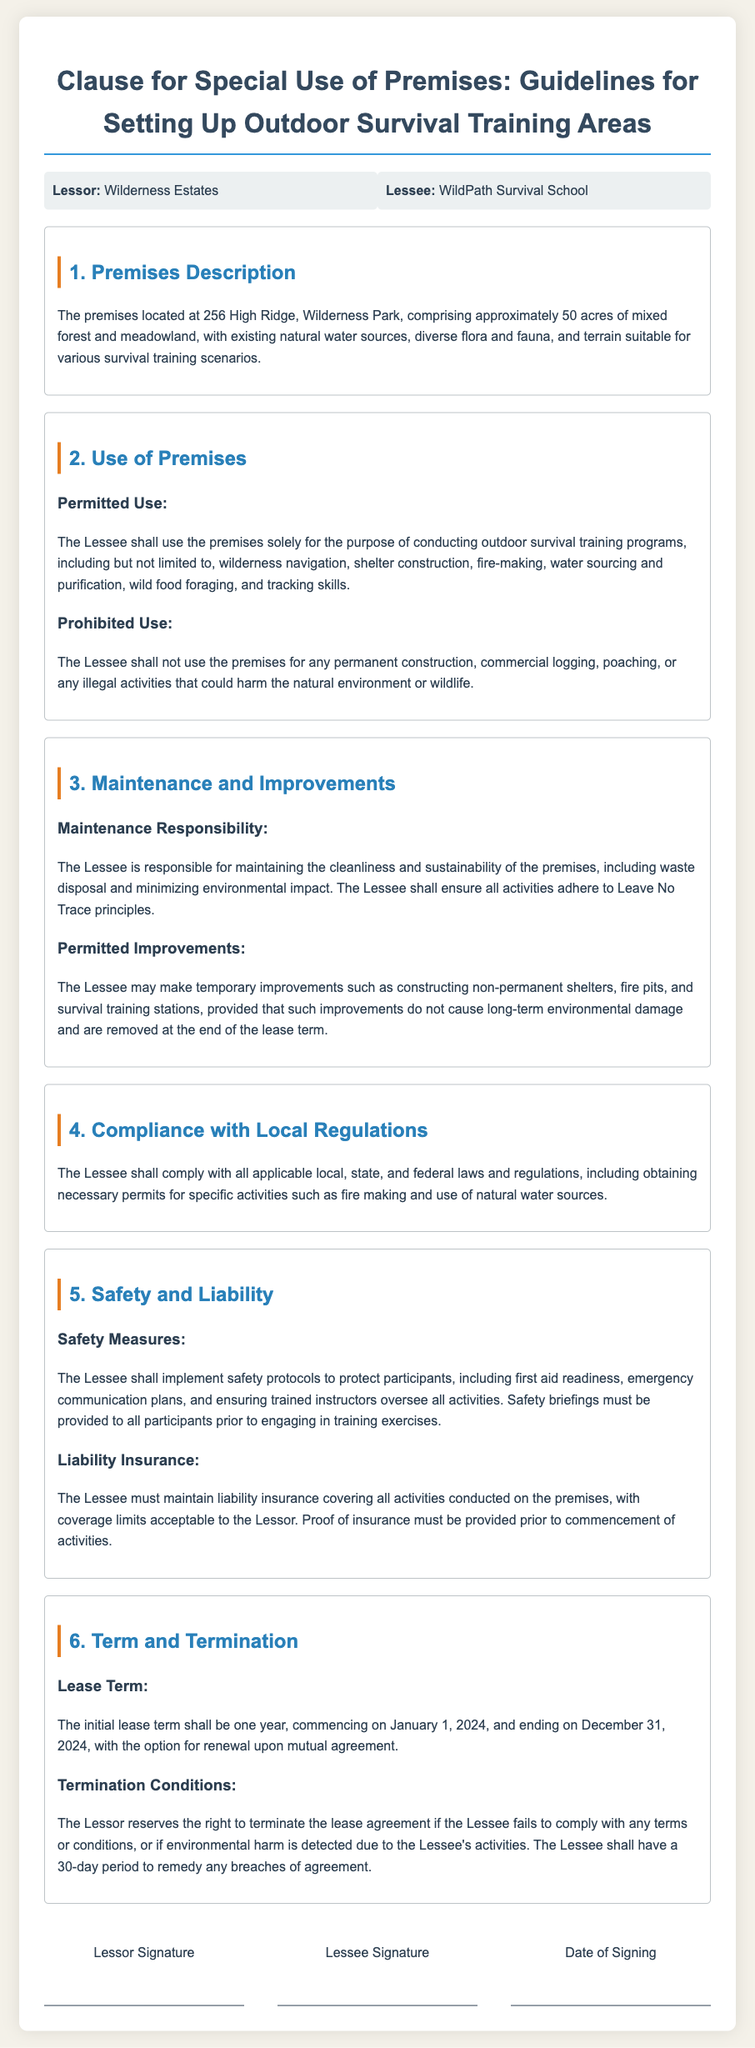What is the address of the premises? The address of the premises is specifically mentioned in the description.
Answer: 256 High Ridge, Wilderness Park What is the size of the premises? The size of the premises is detailed in the description of the document.
Answer: Approximately 50 acres What is the term of the lease? The lease term is specified within the Term and Termination section of the document.
Answer: One year Who is the lessee? The lessee is identified in the parties section of the lease agreement.
Answer: WildPath Survival School What activities are permitted on the premises? The permitted activities are clearly outlined in the use of premises section.
Answer: Conducting outdoor survival training programs What must the lessee maintain according to the lease? The lease specifies maintenance responsibilities within a particular section.
Answer: Cleanliness and sustainability What type of insurance must the lessee maintain? The type of insurance required is mentioned in the safety and liability section.
Answer: Liability insurance What happens if the lessee violates the agreement? The conditions for termination are stipulated in the Term and Termination section.
Answer: Lease termination What principles must the lessee adhere to for maintenance? The document refers to a set of guidelines for environmental responsibility in maintenance.
Answer: Leave No Trace principles 